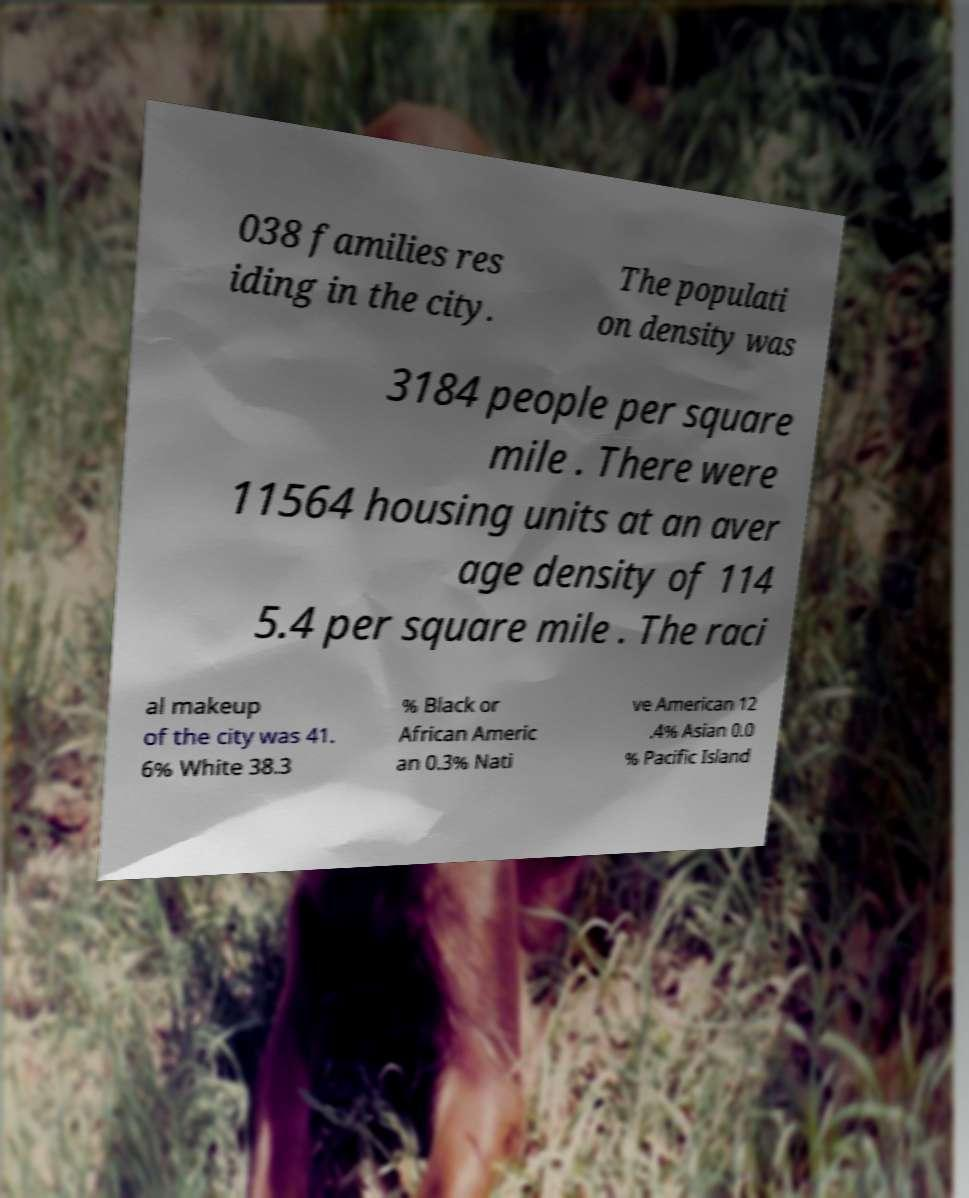Please identify and transcribe the text found in this image. 038 families res iding in the city. The populati on density was 3184 people per square mile . There were 11564 housing units at an aver age density of 114 5.4 per square mile . The raci al makeup of the city was 41. 6% White 38.3 % Black or African Americ an 0.3% Nati ve American 12 .4% Asian 0.0 % Pacific Island 